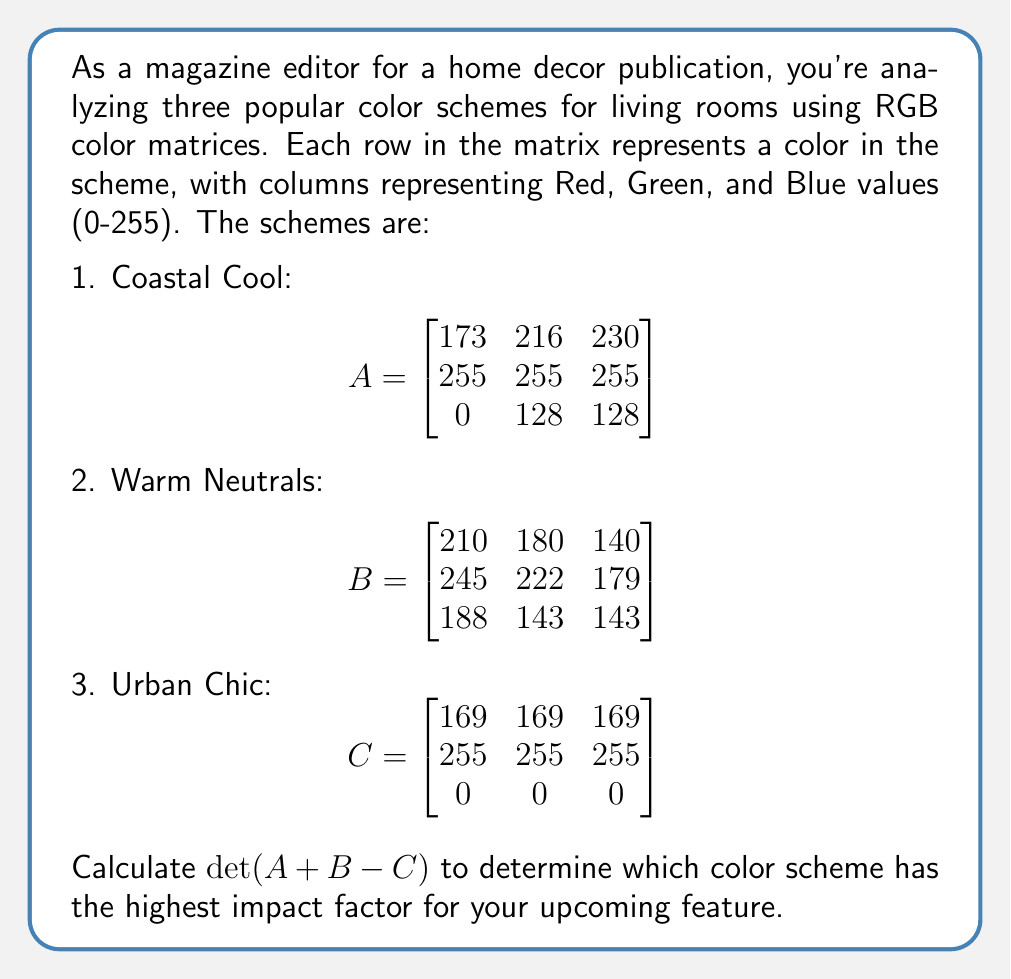Show me your answer to this math problem. Let's approach this step-by-step:

1) First, we need to perform the matrix addition and subtraction: $A + B - C$

$$\begin{bmatrix}
173 & 216 & 230 \\
255 & 255 & 255 \\
0 & 128 & 128
\end{bmatrix} + 
\begin{bmatrix}
210 & 180 & 140 \\
245 & 222 & 179 \\
188 & 143 & 143
\end{bmatrix} - 
\begin{bmatrix}
169 & 169 & 169 \\
255 & 255 & 255 \\
0 & 0 & 0
\end{bmatrix}$$

2) Performing the operations:

$$\begin{bmatrix}
(173+210-169) & (216+180-169) & (230+140-169) \\
(255+245-255) & (255+222-255) & (255+179-255) \\
(0+188-0) & (128+143-0) & (128+143-0)
\end{bmatrix}$$

3) Simplifying:

$$\begin{bmatrix}
214 & 227 & 201 \\
245 & 222 & 179 \\
188 & 271 & 271
\end{bmatrix}$$

4) Now we need to calculate the determinant of this 3x3 matrix. The formula for a 3x3 determinant is:

$$det\begin{pmatrix}
a & b & c \\
d & e & f \\
g & h & i
\end{pmatrix} = a(ei-fh) - b(di-fg) + c(dh-eg)$$

5) Plugging in our values:

$det = 214[(222)(271) - (179)(271)] - 227[(245)(271) - (179)(188)] + 201[(245)(271) - (222)(188)]$

6) Calculating:

$det = 214[60162 - 48509] - 227[66395 - 33652] + 201[66395 - 41736]$

$det = 214(11653) - 227(32743) + 201(24659)$

$det = 2493742 - 7432661 + 4956459$

$det = 17540$

The positive determinant indicates a high impact factor, suggesting this combined color scheme would be visually striking for your feature.
Answer: 17540 